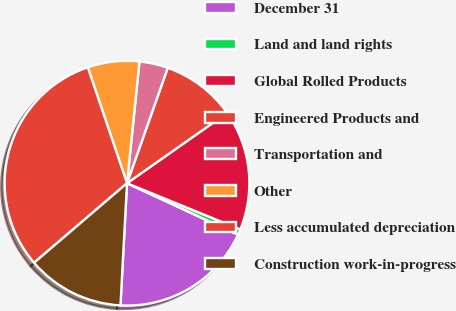Convert chart to OTSL. <chart><loc_0><loc_0><loc_500><loc_500><pie_chart><fcel>December 31<fcel>Land and land rights<fcel>Global Rolled Products<fcel>Engineered Products and<fcel>Transportation and<fcel>Other<fcel>Less accumulated depreciation<fcel>Construction work-in-progress<nl><fcel>18.94%<fcel>0.75%<fcel>15.91%<fcel>9.85%<fcel>3.78%<fcel>6.82%<fcel>31.07%<fcel>12.88%<nl></chart> 